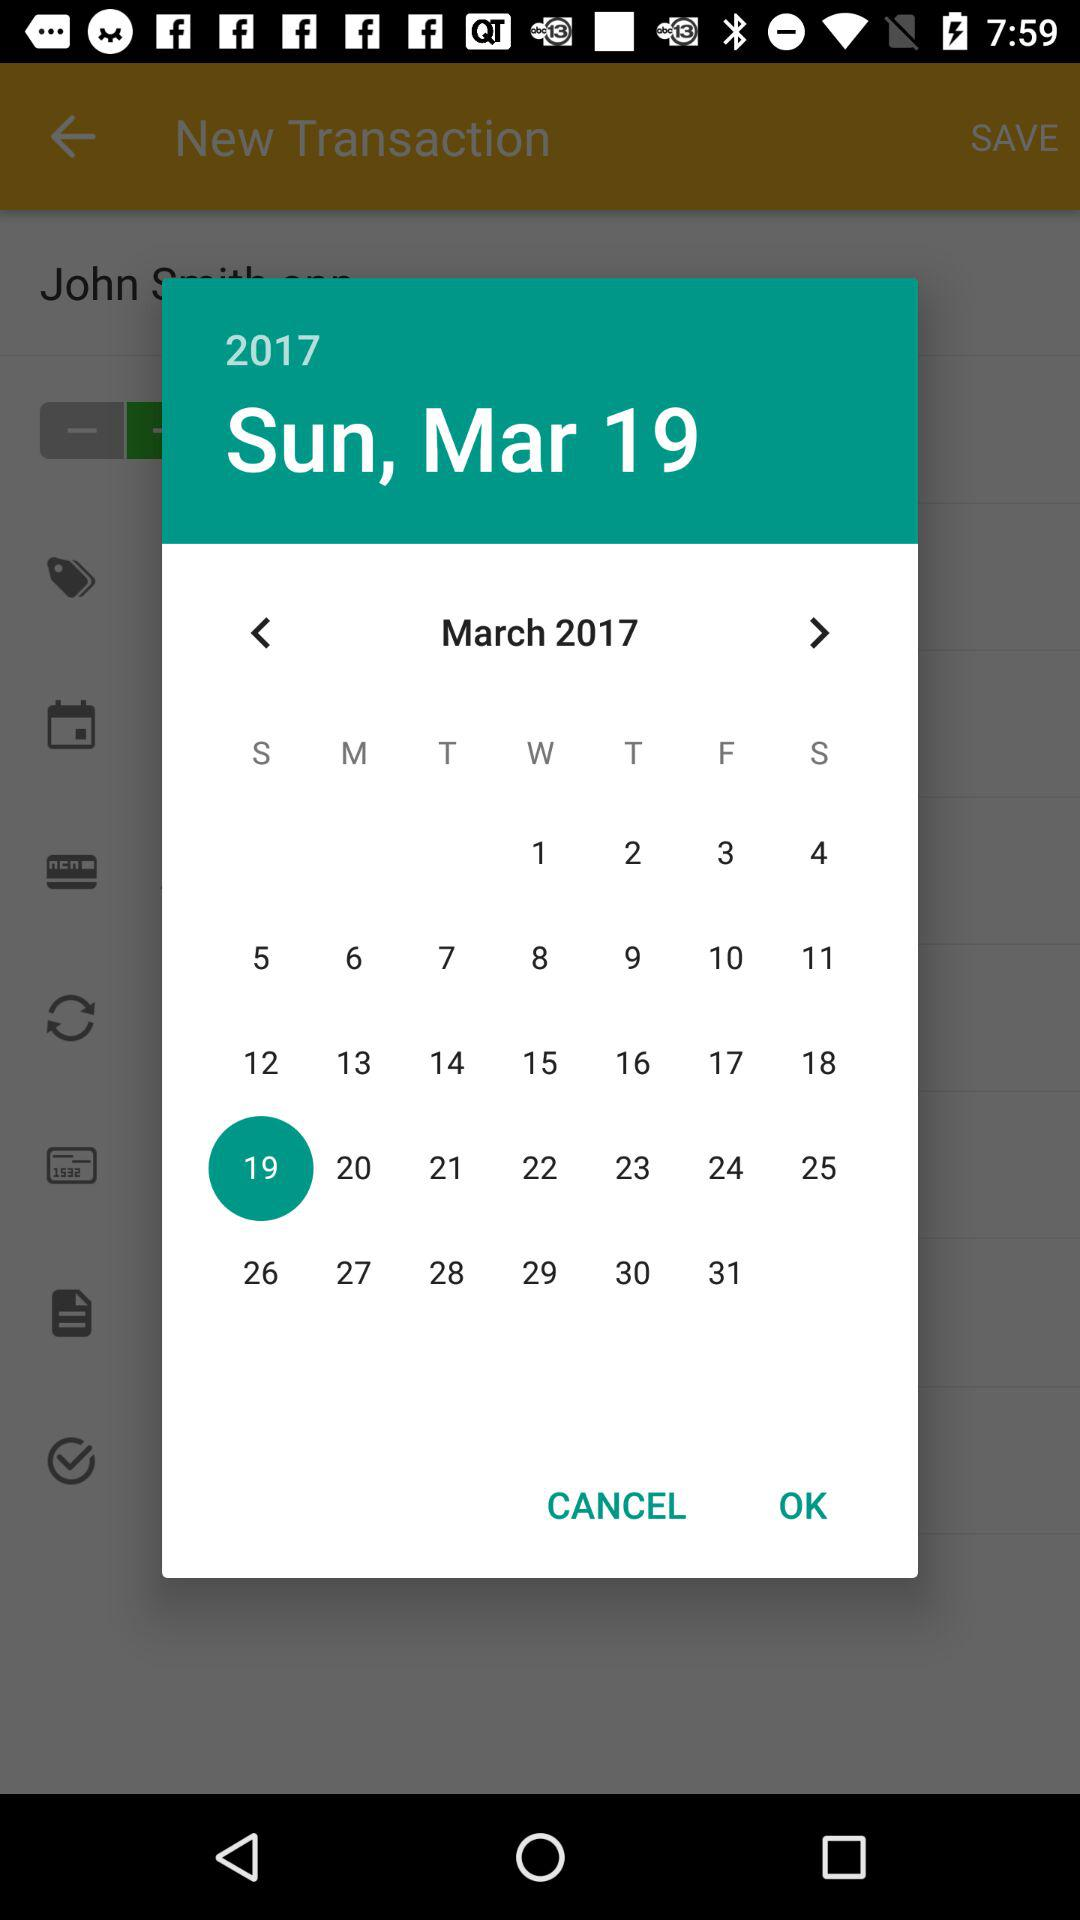What is the day on March 19? The day on March 19 is Sunday. 